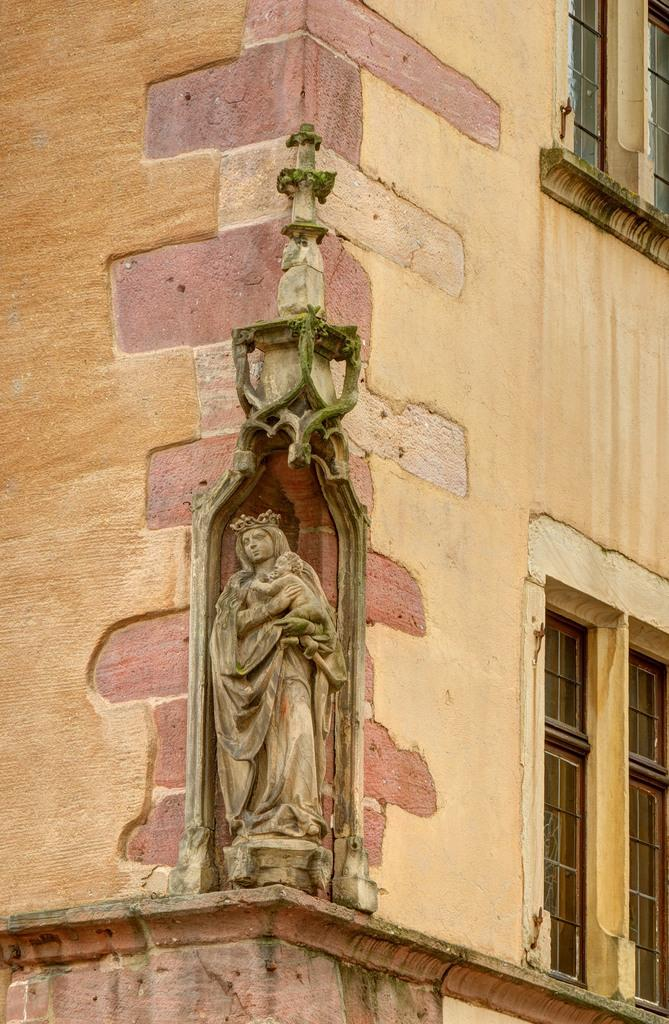What is the main subject of the image? There is a statue in the image. Where is the statue located? The statue is on the wall of a building. Is there any blood visible on the statue in the image? There is no mention of blood in the provided facts, and therefore it cannot be determined from the image. 